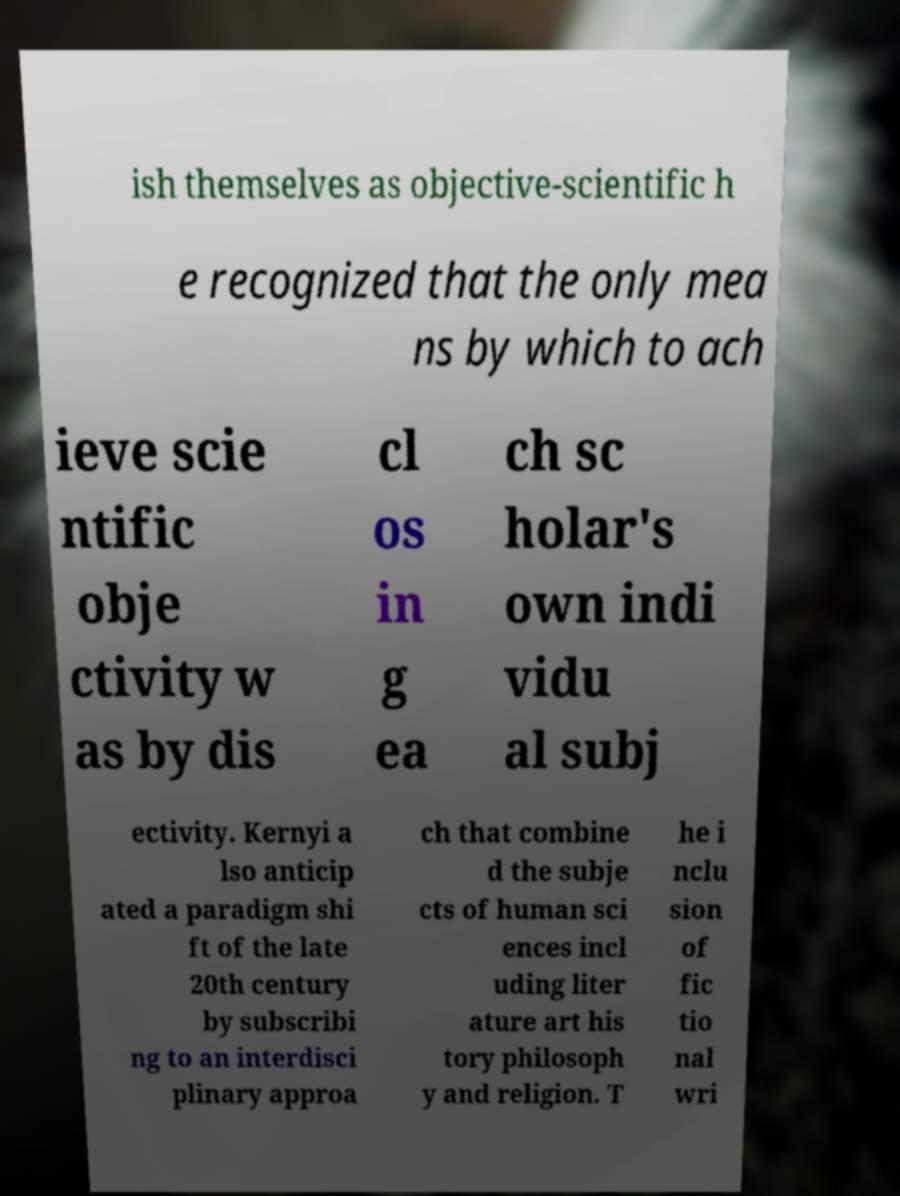There's text embedded in this image that I need extracted. Can you transcribe it verbatim? ish themselves as objective-scientific h e recognized that the only mea ns by which to ach ieve scie ntific obje ctivity w as by dis cl os in g ea ch sc holar's own indi vidu al subj ectivity. Kernyi a lso anticip ated a paradigm shi ft of the late 20th century by subscribi ng to an interdisci plinary approa ch that combine d the subje cts of human sci ences incl uding liter ature art his tory philosoph y and religion. T he i nclu sion of fic tio nal wri 